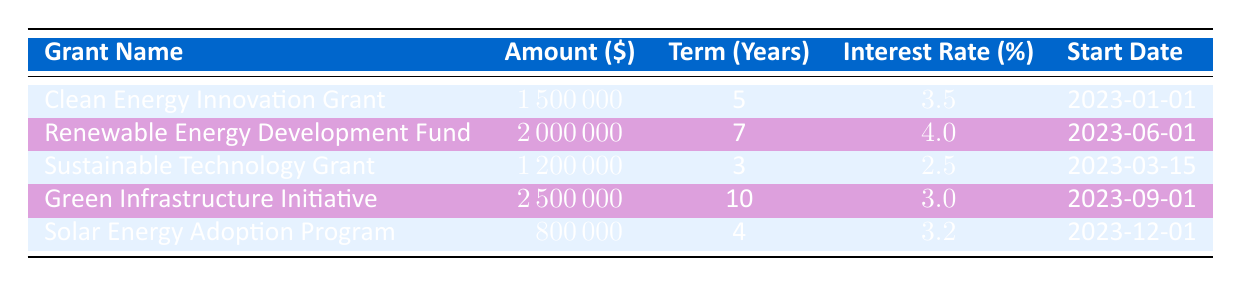What is the allocated amount for the Clean Energy Innovation Grant? The table shows that the Clean Energy Innovation Grant has an allocated amount of 1,500,000.
Answer: 1,500,000 Which grant has the longest term? By examining the 'Term (Years)' column, the Green Infrastructure Initiative has a term of 10 years, which is the longest among the grants listed.
Answer: Green Infrastructure Initiative What is the total allocated amount across all the grants? The total allocated amount can be calculated by adding the allocated amounts: 1,500,000 + 2,000,000 + 1,200,000 + 2,500,000 + 800,000, which equals 8,000,000.
Answer: 8,000,000 Is the interest rate for the Renewable Energy Development Fund higher than that of the Sustainable Technology Grant? The Renewable Energy Development Fund has an interest rate of 4.0%, whereas the Sustainable Technology Grant has an interest rate of 2.5%. Therefore, the statement is true.
Answer: Yes What is the average interest rate of the grants? To find the average interest rate, sum the rates (3.5 + 4.0 + 2.5 + 3.0 + 3.2 = 16.2) and divide by the number of grants (5), which gives an average of 3.24.
Answer: 3.24 